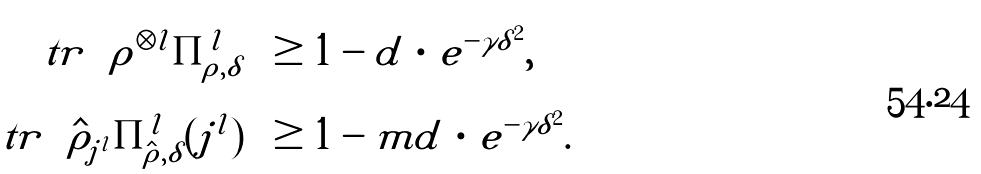Convert formula to latex. <formula><loc_0><loc_0><loc_500><loc_500>\ t r \left ( \rho ^ { \otimes l } \Pi ^ { l } _ { \rho , \delta } \right ) & \geq 1 - d \, \cdot \, e ^ { - \gamma \delta ^ { 2 } } , \\ \ t r \left ( \hat { \rho } _ { j ^ { l } } \Pi ^ { l } _ { \hat { \rho } , \delta } ( j ^ { l } ) \right ) & \geq 1 - m d \, \cdot \, e ^ { - \gamma \delta ^ { 2 } } .</formula> 